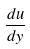<formula> <loc_0><loc_0><loc_500><loc_500>\frac { d u } { d y }</formula> 